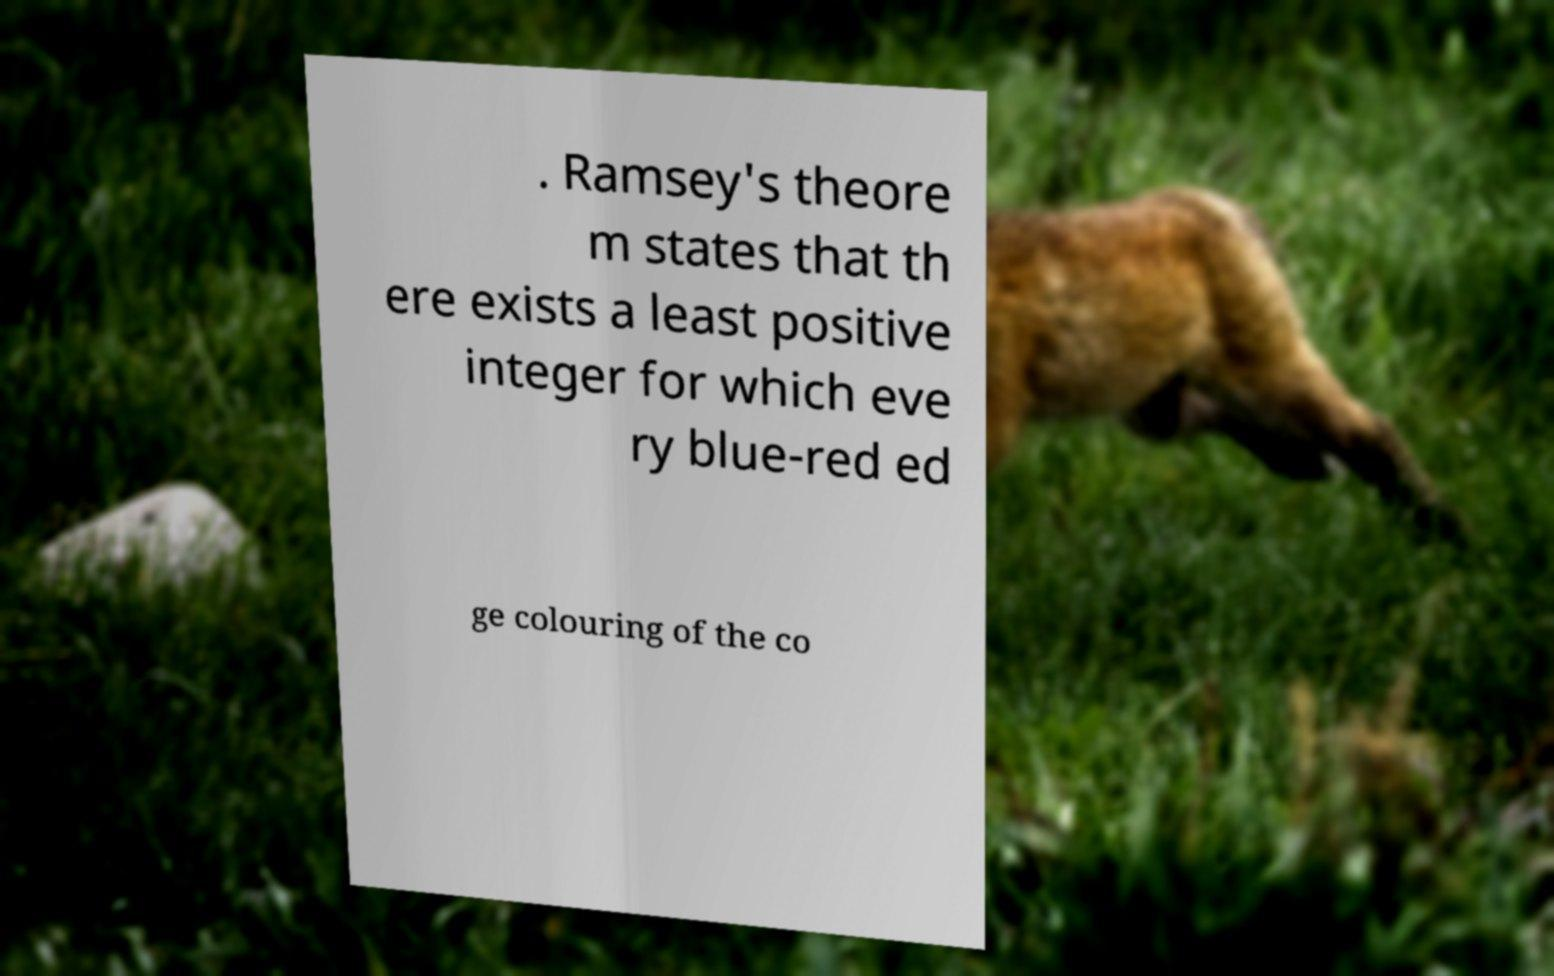Please read and relay the text visible in this image. What does it say? . Ramsey's theore m states that th ere exists a least positive integer for which eve ry blue-red ed ge colouring of the co 